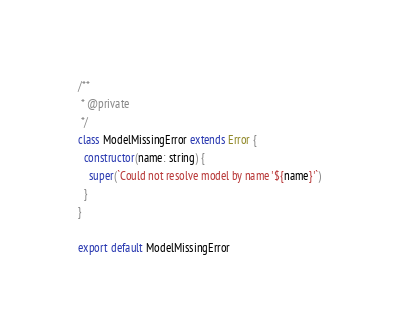Convert code to text. <code><loc_0><loc_0><loc_500><loc_500><_JavaScript_>/**
 * @private
 */
class ModelMissingError extends Error {
  constructor(name: string) {
    super(`Could not resolve model by name '${name}'`)
  }
}

export default ModelMissingError
</code> 